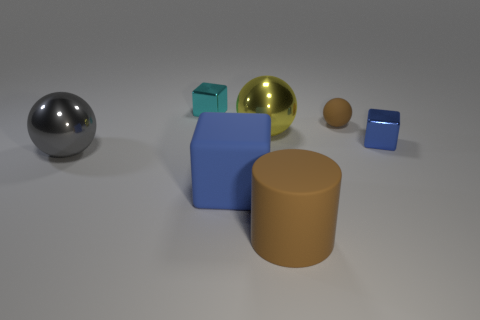What shape is the big gray thing that is made of the same material as the cyan thing?
Keep it short and to the point. Sphere. What number of other things are the same shape as the large blue matte object?
Your answer should be very brief. 2. How many big spheres are on the right side of the blue matte cube?
Provide a succinct answer. 1. Does the blue thing that is in front of the gray shiny object have the same size as the gray metal sphere in front of the tiny blue object?
Offer a terse response. Yes. What number of other things are the same size as the yellow metal sphere?
Keep it short and to the point. 3. What is the material of the small cube in front of the small block behind the tiny cube that is right of the cyan thing?
Offer a terse response. Metal. Is the size of the brown rubber sphere the same as the shiny sphere on the right side of the big gray ball?
Your response must be concise. No. There is a thing that is in front of the brown ball and right of the big brown matte thing; what is its size?
Provide a short and direct response. Small. Is there a large cylinder of the same color as the small rubber sphere?
Ensure brevity in your answer.  Yes. What is the color of the rubber thing behind the big gray thing behind the brown matte cylinder?
Offer a very short reply. Brown. 